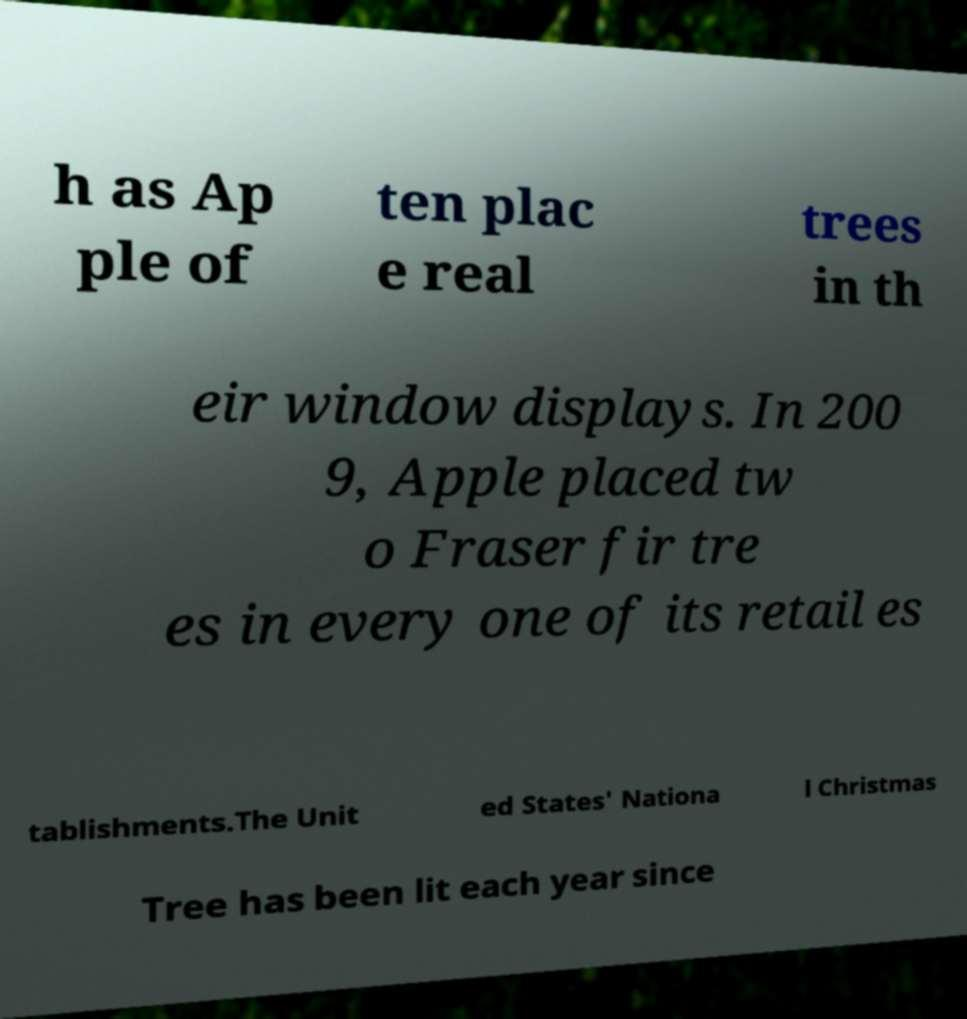I need the written content from this picture converted into text. Can you do that? h as Ap ple of ten plac e real trees in th eir window displays. In 200 9, Apple placed tw o Fraser fir tre es in every one of its retail es tablishments.The Unit ed States' Nationa l Christmas Tree has been lit each year since 